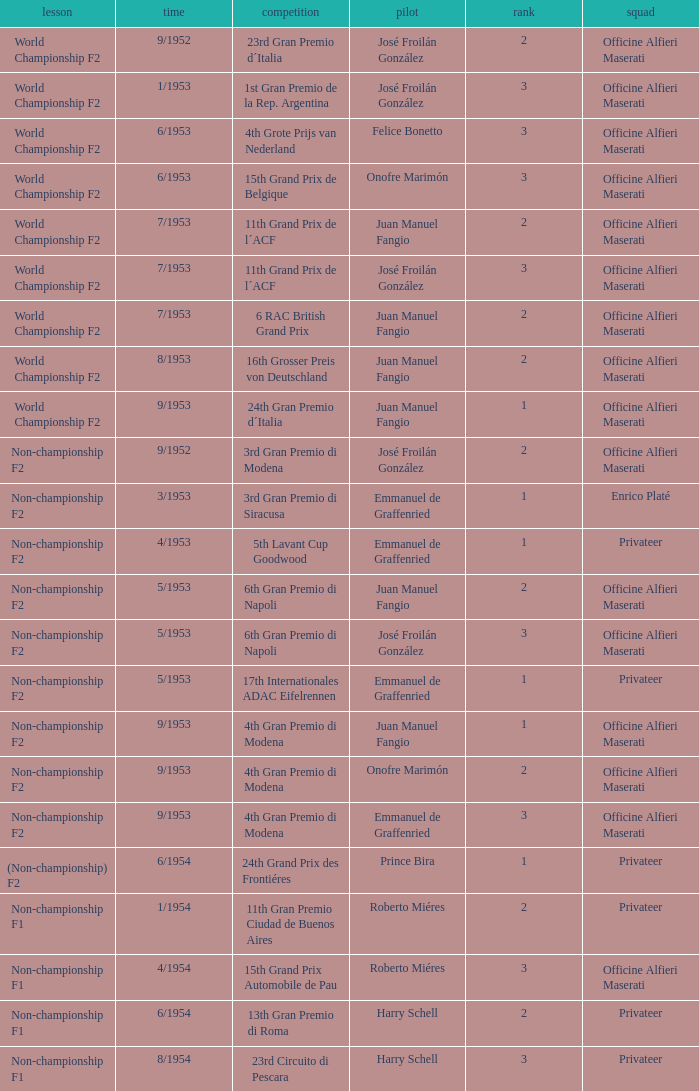What driver has a team of officine alfieri maserati and belongs to the class of non-championship f2 and has a position of 2, as well as a date of 9/1952? José Froilán González. 